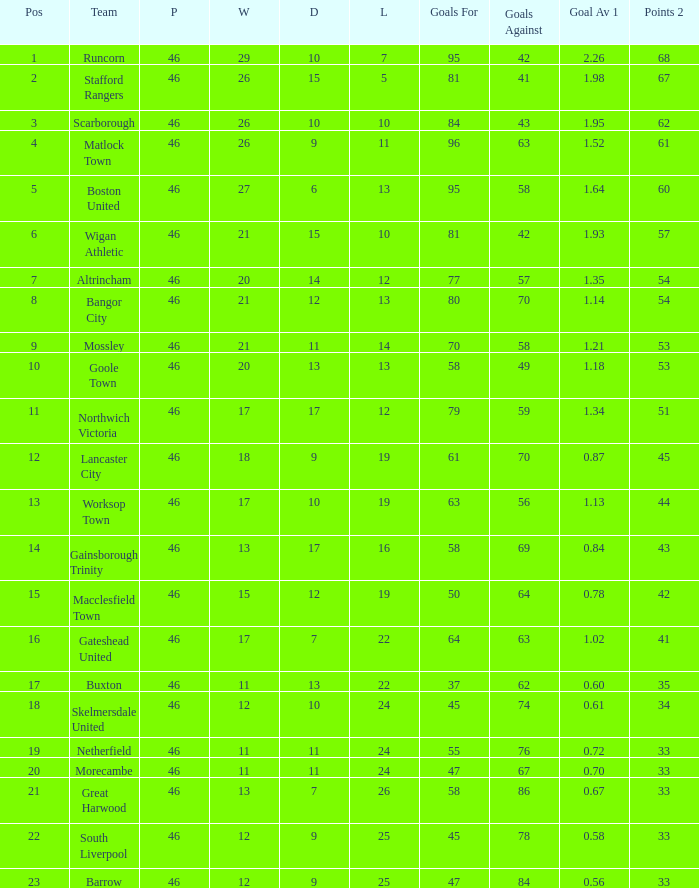List every loss having a mean of 14.0. 